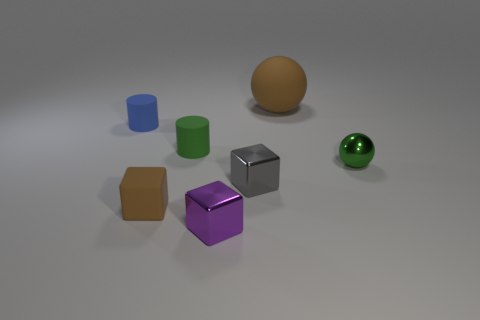What number of tiny objects are the same color as the small metallic ball? There's one small object that shares the color with the small metallic ball: the shiny green sphere to the right. 